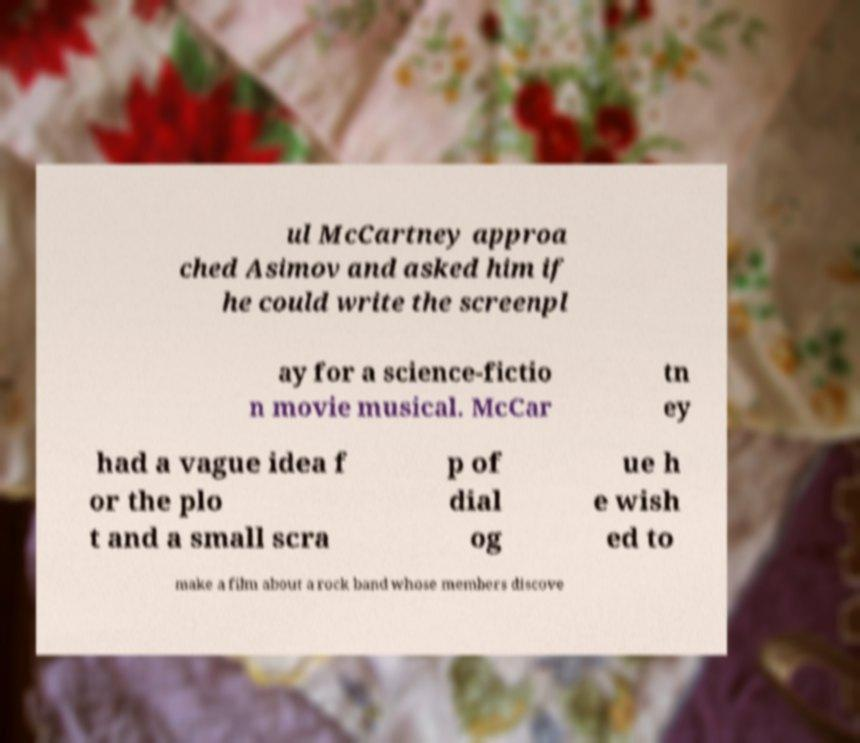Could you extract and type out the text from this image? ul McCartney approa ched Asimov and asked him if he could write the screenpl ay for a science-fictio n movie musical. McCar tn ey had a vague idea f or the plo t and a small scra p of dial og ue h e wish ed to make a film about a rock band whose members discove 